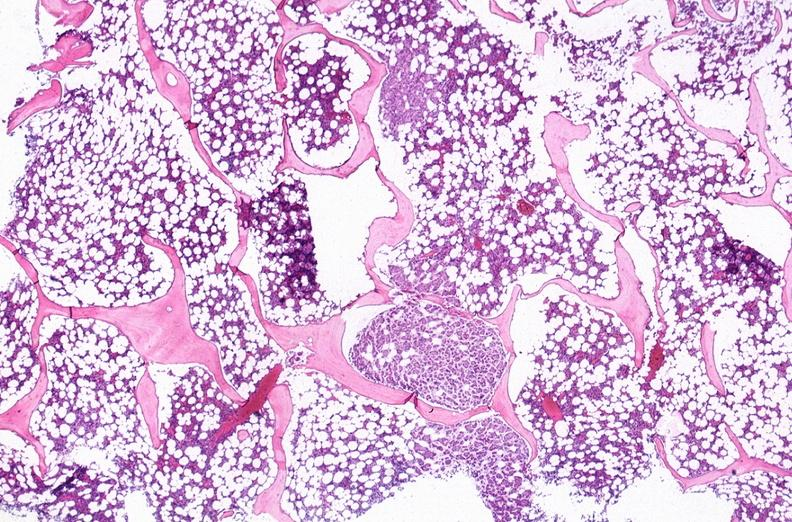s vasculature present?
Answer the question using a single word or phrase. No 